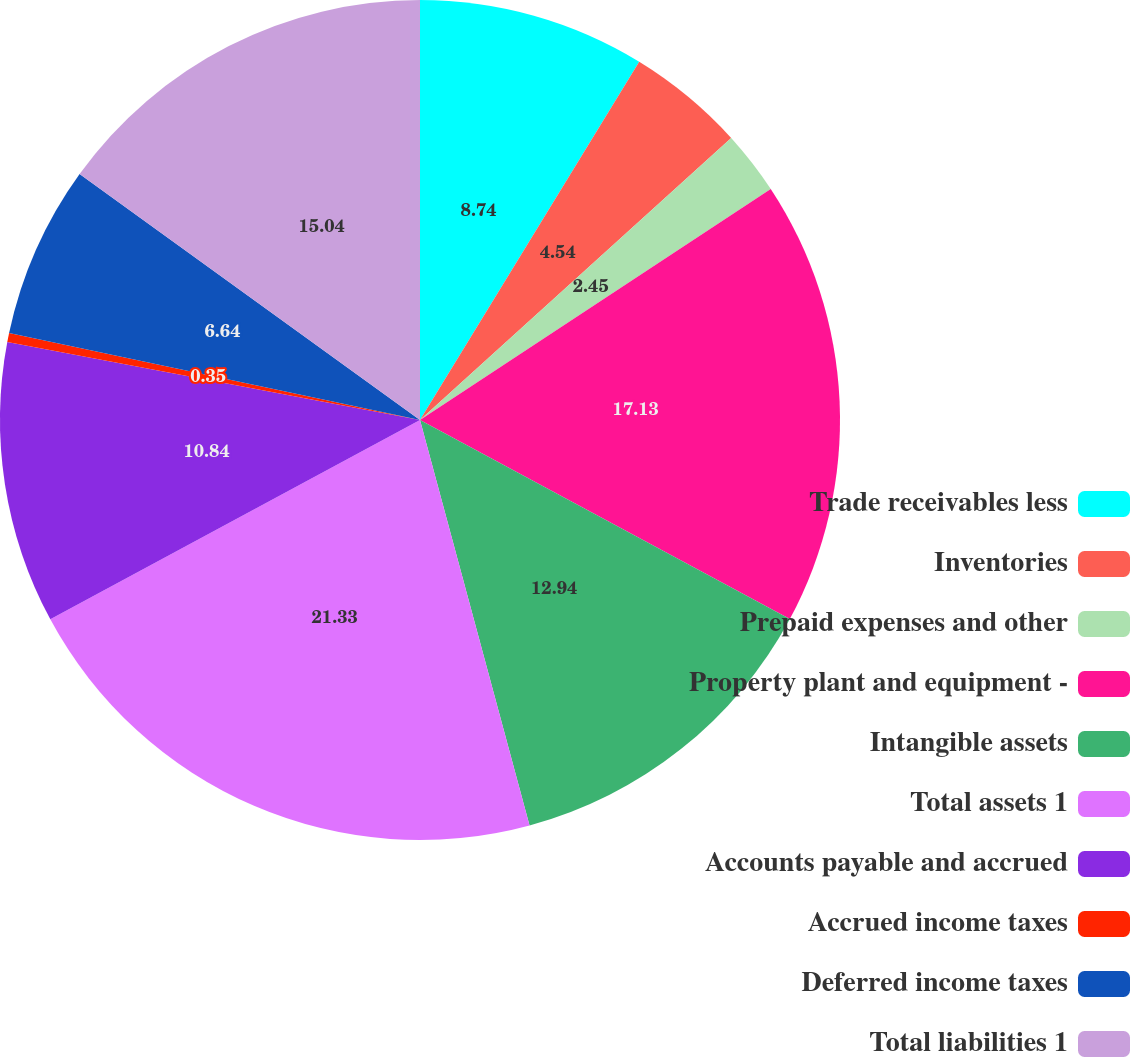Convert chart to OTSL. <chart><loc_0><loc_0><loc_500><loc_500><pie_chart><fcel>Trade receivables less<fcel>Inventories<fcel>Prepaid expenses and other<fcel>Property plant and equipment -<fcel>Intangible assets<fcel>Total assets 1<fcel>Accounts payable and accrued<fcel>Accrued income taxes<fcel>Deferred income taxes<fcel>Total liabilities 1<nl><fcel>8.74%<fcel>4.54%<fcel>2.45%<fcel>17.13%<fcel>12.94%<fcel>21.33%<fcel>10.84%<fcel>0.35%<fcel>6.64%<fcel>15.04%<nl></chart> 